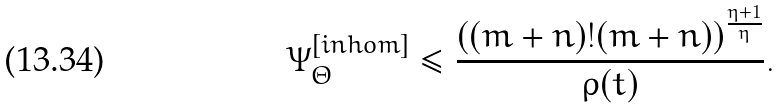<formula> <loc_0><loc_0><loc_500><loc_500>\Psi _ { \Theta } ^ { [ i n h o m ] } \leq \frac { ( ( m + n ) ! ( m + n ) ) ^ { \frac { \eta + 1 } { \eta } } } { \rho ( t ) } .</formula> 